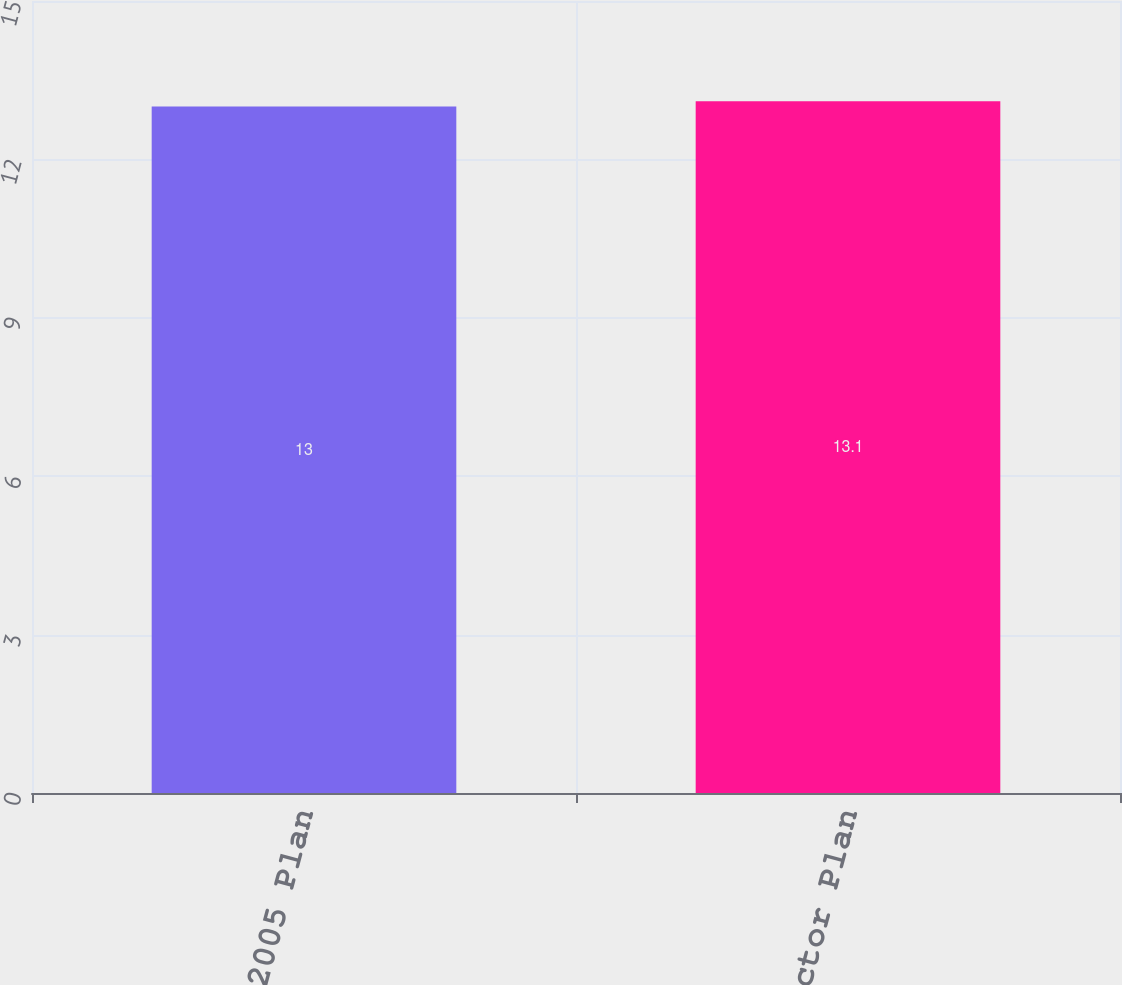<chart> <loc_0><loc_0><loc_500><loc_500><bar_chart><fcel>2005 Plan<fcel>Director Plan<nl><fcel>13<fcel>13.1<nl></chart> 